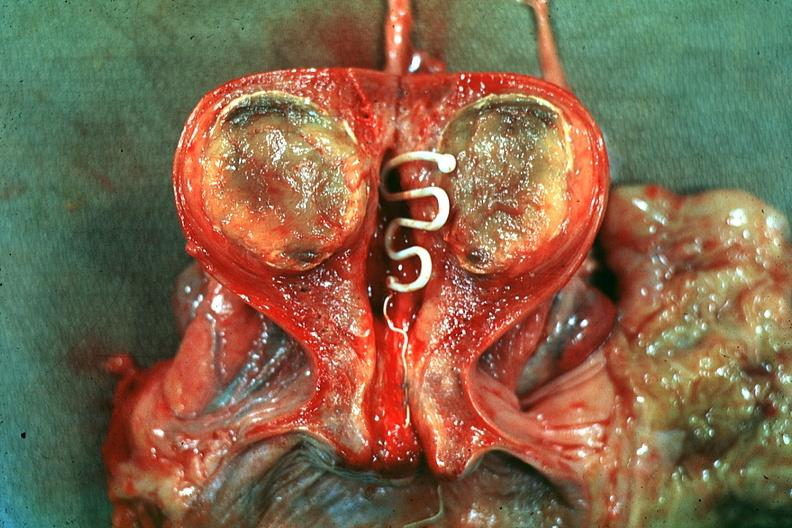s uterus present?
Answer the question using a single word or phrase. Yes 